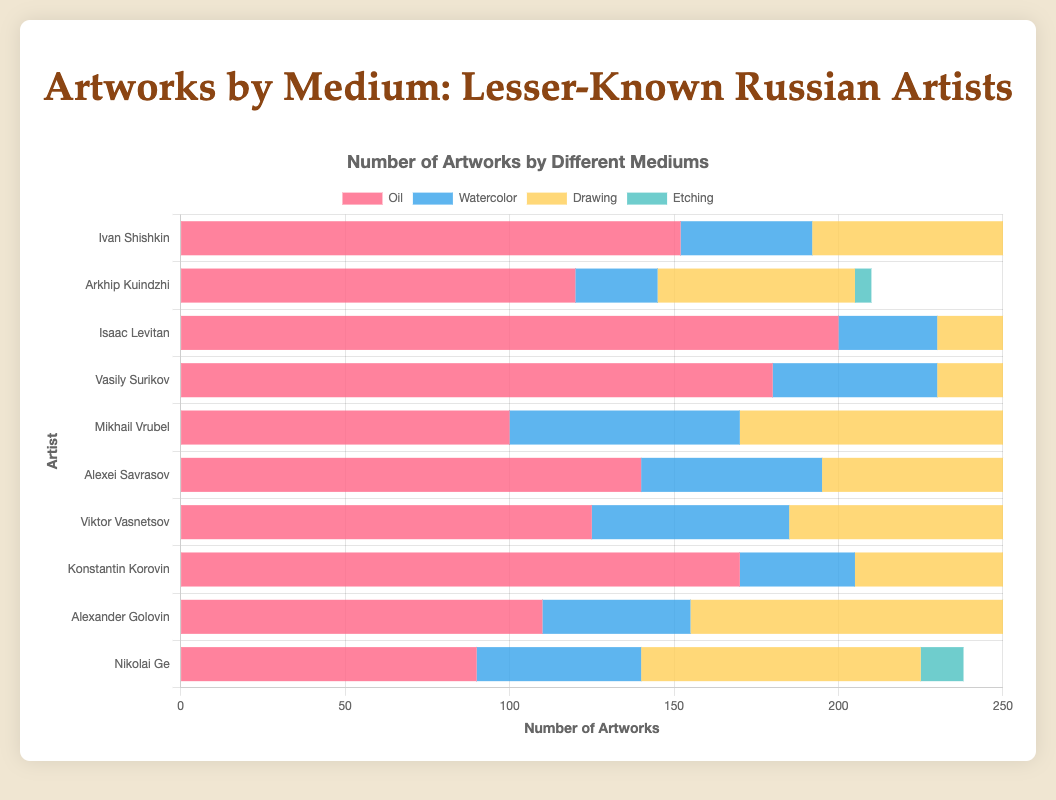Which artist has the highest number of oil paintings? The bar corresponding to oil paintings for Isaac Levitan reaches the highest value.
Answer: Isaac Levitan How many drawings did Mikhail Vrubel create? By looking at the section of the bar for Mikhail Vrubel related to drawings, it indicates 120.
Answer: 120 Which artist produced more etchings: Ivan Shishkin or Arkhip Kuindzhi? Ivan Shishkin's bar for etchings is higher than that of Arkhip Kuindzhi's.
Answer: Ivan Shishkin Which medium did Konstantin Korovin use the most? The longest section of the bar for Konstantin Korovin corresponds to oil paintings.
Answer: Oil What is the total number of artworks created by Vasily Surikov? Sum the values of oil, watercolor, drawing, and etching artworks for Vasily Surikov (180 + 50 + 90 + 10).
Answer: 330 Compare the number of watercolor artworks created by Alexei Savrasov and Viktor Vasnetsov. Which one created more? The bar representing watercolors for Viktor Vasnetsov is slightly longer than that of Alexei Savrasov.
Answer: Viktor Vasnetsov How many more oil paintings did Isaac Levitan create compared to Nikolai Ge? Subtract the number of oil paintings by Nikolai Ge from that by Isaac Levitan (200 - 90).
Answer: 110 Rank the artists by the number of drawings from highest to lowest. The lengths of the drawing sections for the artists are ordered as follows: Mikhail Vrubel, Konstantin Korovin, Alexander Golovin, Vasily Surikov, Ivan Shishkin, Viktor Vasnetsov, Isaac Levitan, Alexei Savrasov, Nikolai Ge, Arkhip Kuindzhi.
Answer: Mikhail Vrubel > Konstantin Korovin > Alexander Golovin > Vasily Surikov > Ivan Shishkin > Viktor Vasnetsov > Isaac Levitan > Alexei Savrasov > Nikolai Ge > Arkhip Kuindzhi Which artist has the smallest total number of artworks across all mediums? The artist with the shortest combined bar length across all mediums is Arkhip Kuindzhi.
Answer: Arkhip Kuindzhi 